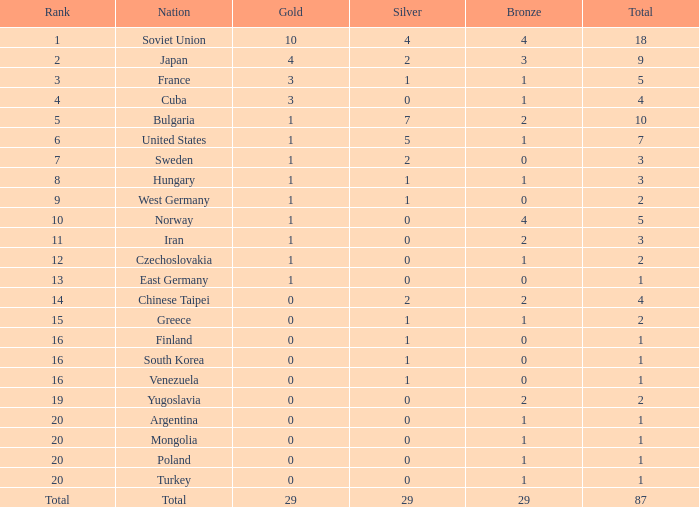What is the average number of bronze medals for total of all nations? 29.0. 